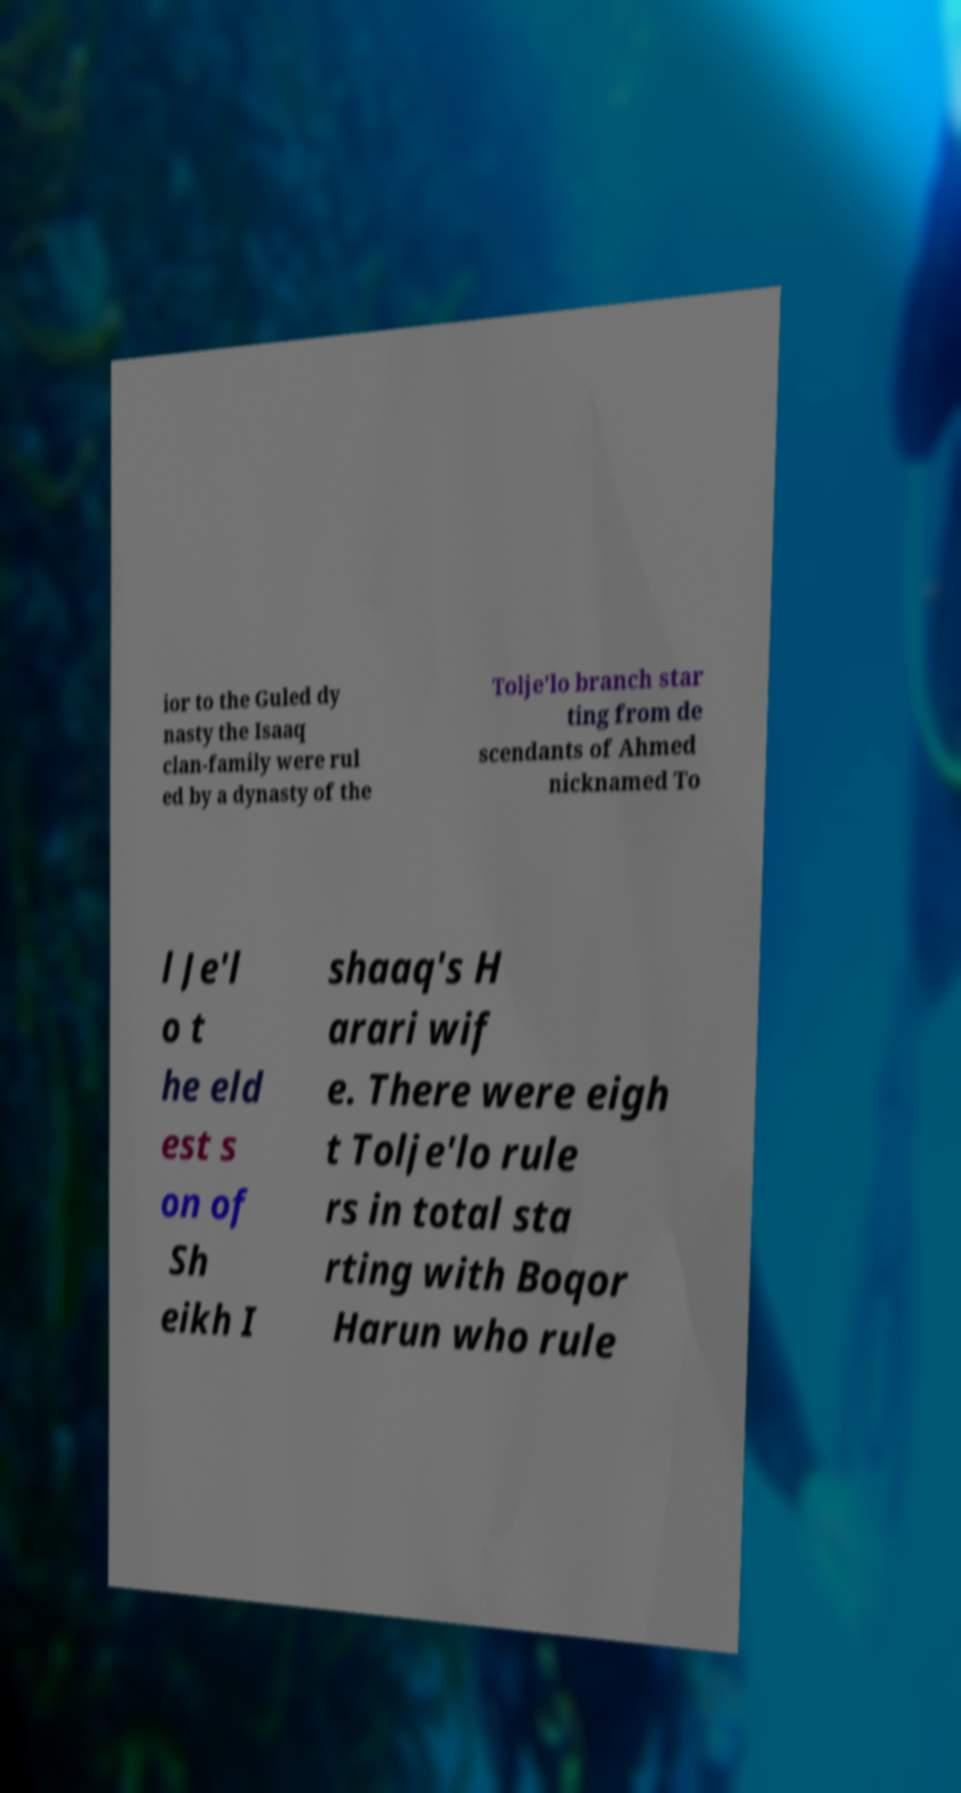For documentation purposes, I need the text within this image transcribed. Could you provide that? ior to the Guled dy nasty the Isaaq clan-family were rul ed by a dynasty of the Tolje'lo branch star ting from de scendants of Ahmed nicknamed To l Je'l o t he eld est s on of Sh eikh I shaaq's H arari wif e. There were eigh t Tolje'lo rule rs in total sta rting with Boqor Harun who rule 